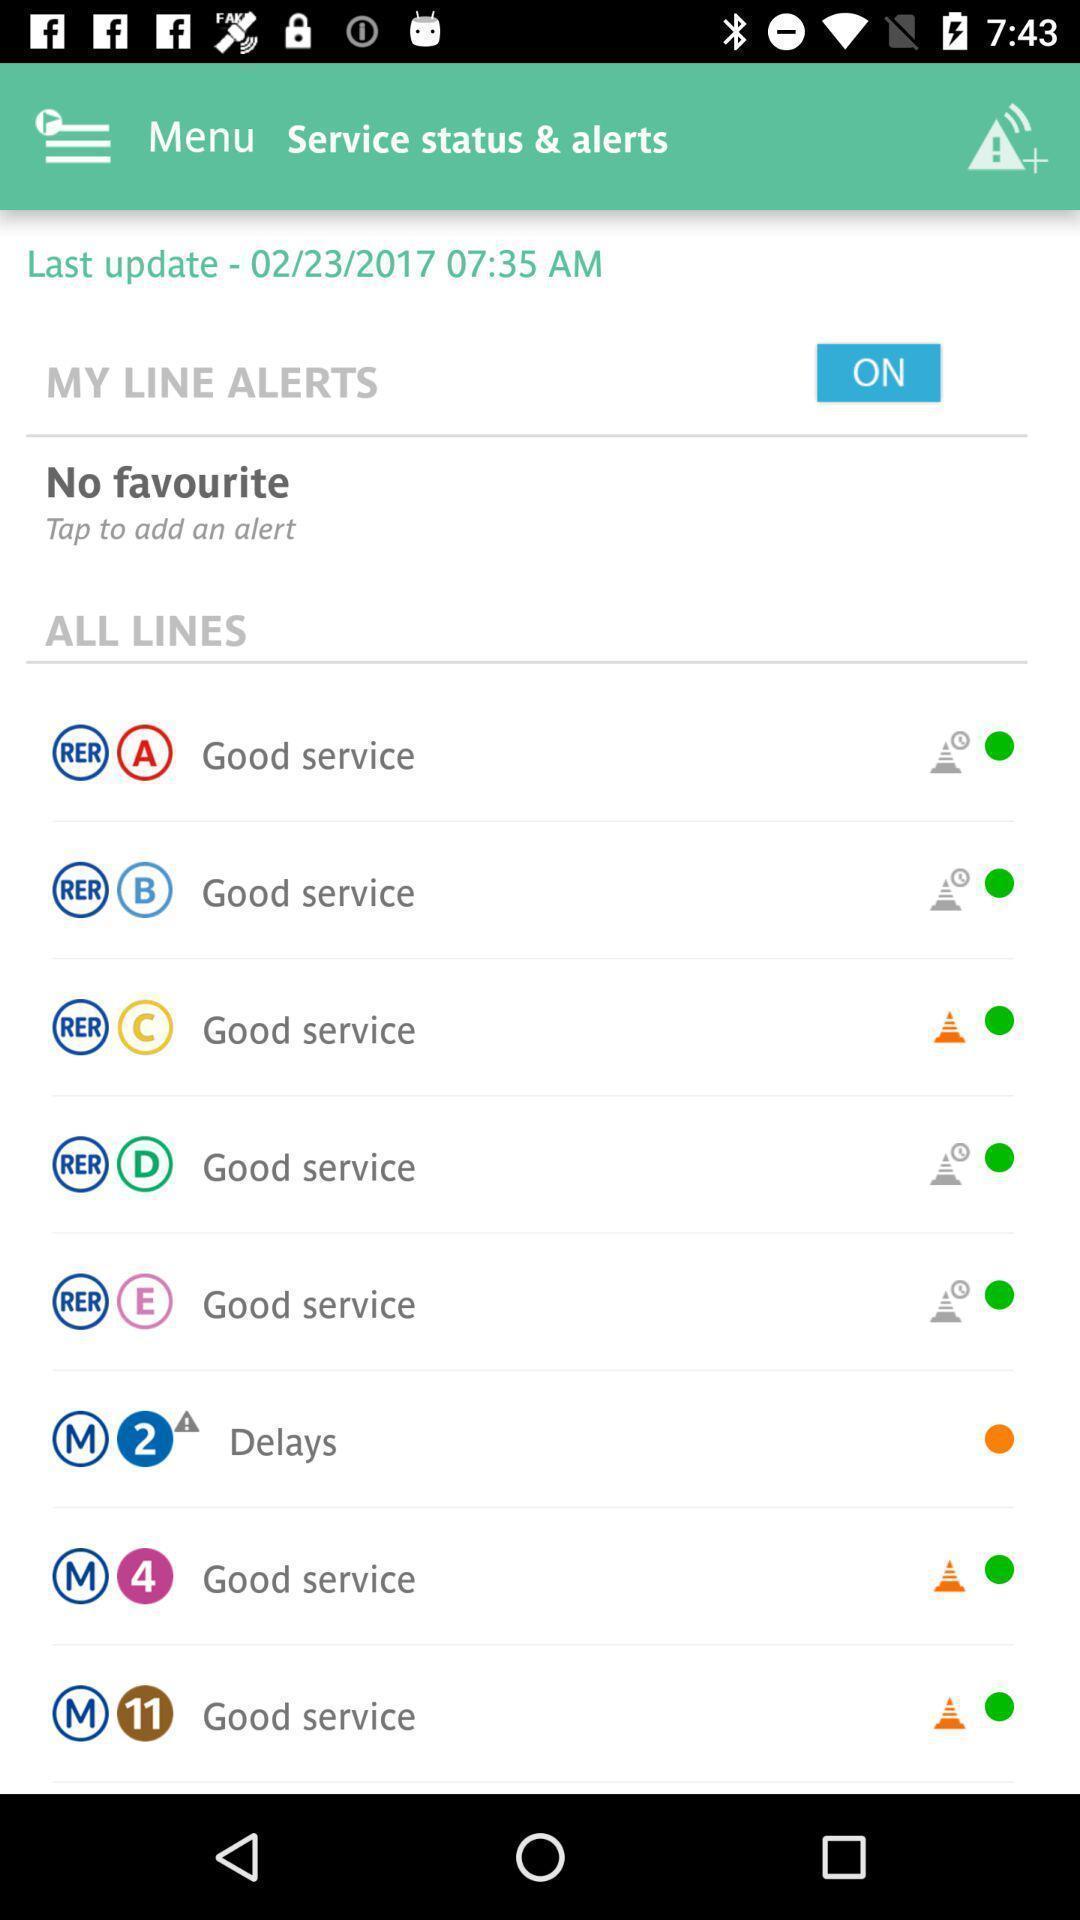Give me a summary of this screen capture. Screen shows about menu and line alerts. 